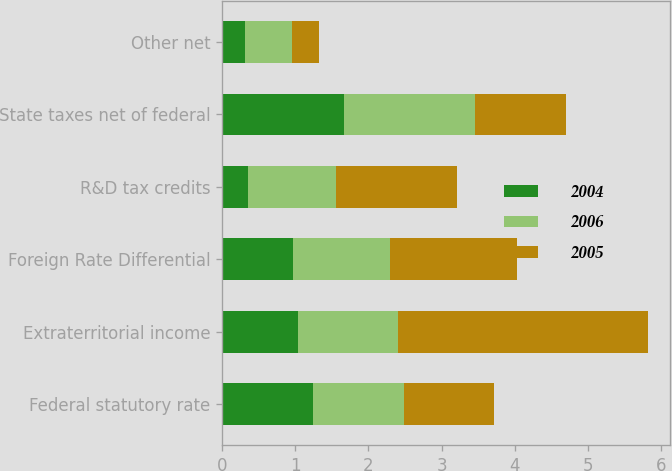Convert chart to OTSL. <chart><loc_0><loc_0><loc_500><loc_500><stacked_bar_chart><ecel><fcel>Federal statutory rate<fcel>Extraterritorial income<fcel>Foreign Rate Differential<fcel>R&D tax credits<fcel>State taxes net of federal<fcel>Other net<nl><fcel>2004<fcel>1.24<fcel>1.04<fcel>0.97<fcel>0.36<fcel>1.67<fcel>0.31<nl><fcel>2006<fcel>1.24<fcel>1.36<fcel>1.33<fcel>1.2<fcel>1.79<fcel>0.65<nl><fcel>2005<fcel>1.24<fcel>3.42<fcel>1.73<fcel>1.65<fcel>1.24<fcel>0.37<nl></chart> 